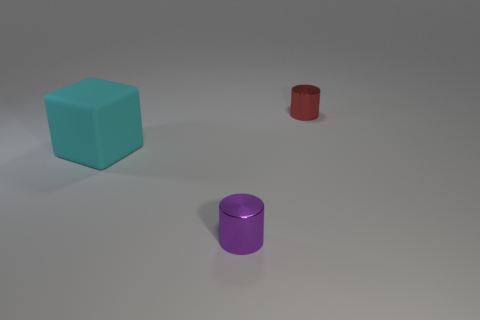Is the material of the purple cylinder the same as the cyan cube to the left of the red cylinder?
Ensure brevity in your answer.  No. What is the shape of the thing that is to the left of the cylinder that is in front of the red metallic cylinder?
Provide a short and direct response. Cube. Is the size of the shiny object in front of the red object the same as the small red object?
Offer a very short reply. Yes. How many other things are the same shape as the large object?
Keep it short and to the point. 0. Do the small metal thing that is behind the matte object and the block have the same color?
Give a very brief answer. No. Are there any metal things that have the same color as the block?
Offer a terse response. No. What number of small red metal things are behind the block?
Make the answer very short. 1. What number of other objects are there of the same size as the red cylinder?
Provide a short and direct response. 1. Is the material of the cylinder to the left of the red cylinder the same as the tiny thing that is behind the purple cylinder?
Offer a very short reply. Yes. There is a cylinder that is the same size as the purple thing; what color is it?
Ensure brevity in your answer.  Red. 